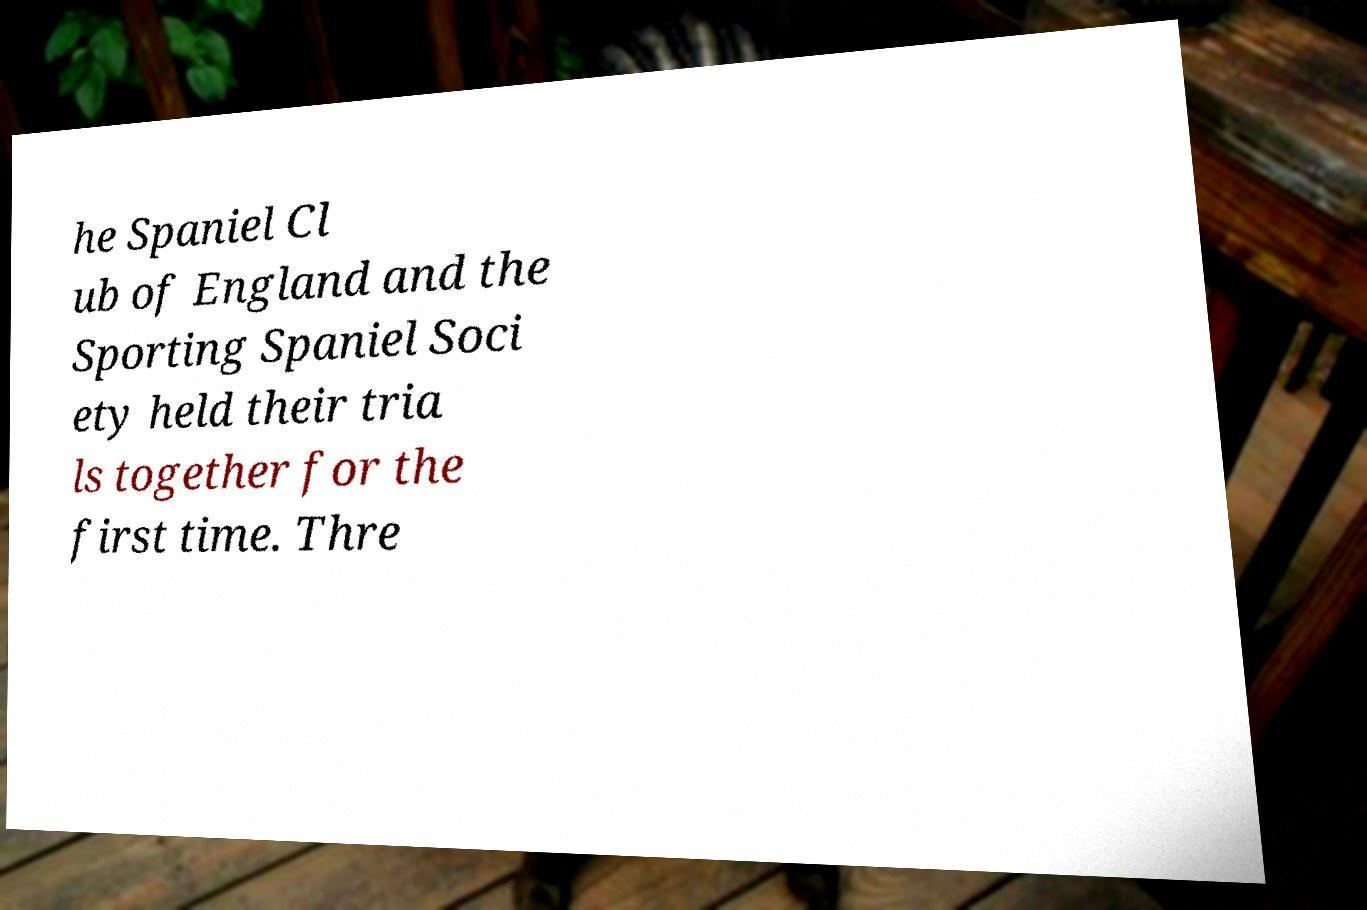For documentation purposes, I need the text within this image transcribed. Could you provide that? he Spaniel Cl ub of England and the Sporting Spaniel Soci ety held their tria ls together for the first time. Thre 